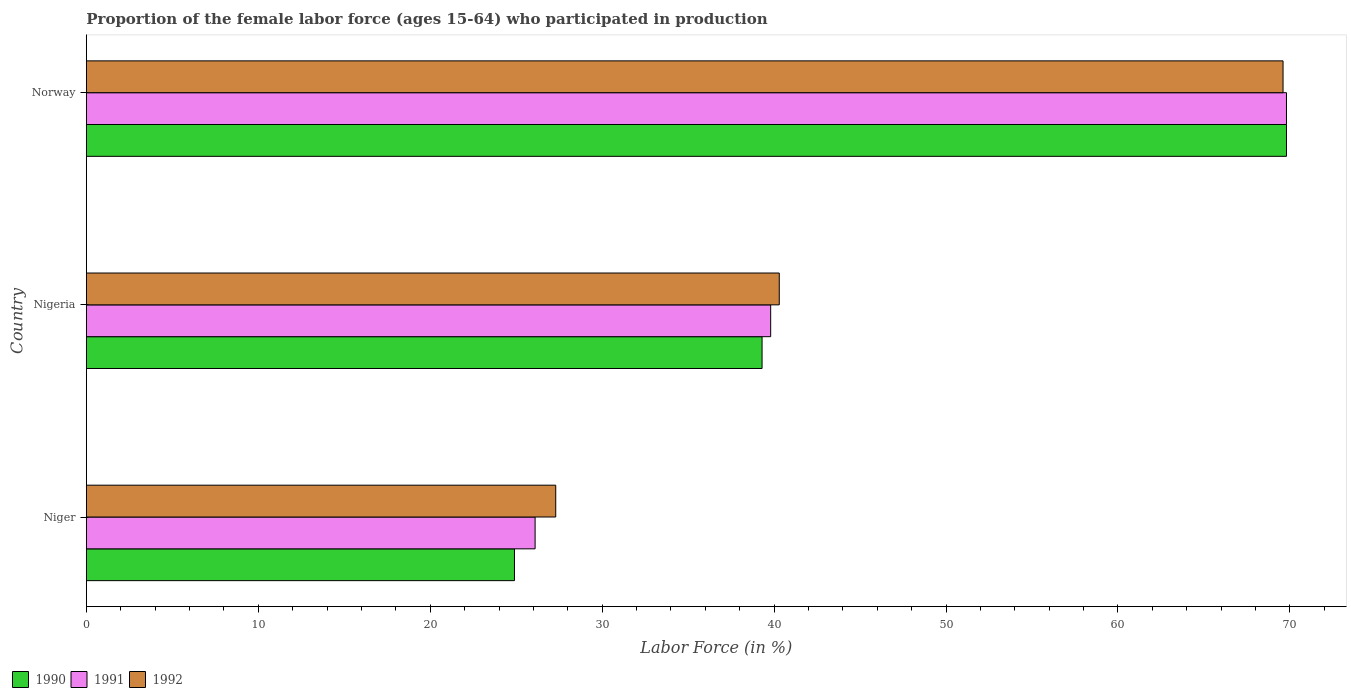How many different coloured bars are there?
Give a very brief answer. 3. Are the number of bars per tick equal to the number of legend labels?
Provide a short and direct response. Yes. Are the number of bars on each tick of the Y-axis equal?
Make the answer very short. Yes. What is the label of the 3rd group of bars from the top?
Your answer should be very brief. Niger. In how many cases, is the number of bars for a given country not equal to the number of legend labels?
Your answer should be very brief. 0. What is the proportion of the female labor force who participated in production in 1990 in Norway?
Your response must be concise. 69.8. Across all countries, what is the maximum proportion of the female labor force who participated in production in 1991?
Provide a succinct answer. 69.8. Across all countries, what is the minimum proportion of the female labor force who participated in production in 1992?
Give a very brief answer. 27.3. In which country was the proportion of the female labor force who participated in production in 1991 maximum?
Keep it short and to the point. Norway. In which country was the proportion of the female labor force who participated in production in 1990 minimum?
Keep it short and to the point. Niger. What is the total proportion of the female labor force who participated in production in 1992 in the graph?
Make the answer very short. 137.2. What is the difference between the proportion of the female labor force who participated in production in 1992 in Niger and that in Nigeria?
Offer a terse response. -13. What is the difference between the proportion of the female labor force who participated in production in 1992 in Norway and the proportion of the female labor force who participated in production in 1990 in Nigeria?
Offer a very short reply. 30.3. What is the average proportion of the female labor force who participated in production in 1992 per country?
Provide a succinct answer. 45.73. What is the difference between the proportion of the female labor force who participated in production in 1991 and proportion of the female labor force who participated in production in 1992 in Niger?
Your response must be concise. -1.2. What is the ratio of the proportion of the female labor force who participated in production in 1991 in Nigeria to that in Norway?
Offer a terse response. 0.57. Is the proportion of the female labor force who participated in production in 1991 in Niger less than that in Norway?
Offer a terse response. Yes. Is the difference between the proportion of the female labor force who participated in production in 1991 in Niger and Nigeria greater than the difference between the proportion of the female labor force who participated in production in 1992 in Niger and Nigeria?
Make the answer very short. No. What is the difference between the highest and the second highest proportion of the female labor force who participated in production in 1991?
Offer a very short reply. 30. What is the difference between the highest and the lowest proportion of the female labor force who participated in production in 1991?
Give a very brief answer. 43.7. Is the sum of the proportion of the female labor force who participated in production in 1990 in Nigeria and Norway greater than the maximum proportion of the female labor force who participated in production in 1992 across all countries?
Offer a terse response. Yes. What does the 3rd bar from the bottom in Norway represents?
Provide a succinct answer. 1992. Is it the case that in every country, the sum of the proportion of the female labor force who participated in production in 1991 and proportion of the female labor force who participated in production in 1992 is greater than the proportion of the female labor force who participated in production in 1990?
Keep it short and to the point. Yes. Are all the bars in the graph horizontal?
Your answer should be very brief. Yes. How many countries are there in the graph?
Your answer should be very brief. 3. What is the difference between two consecutive major ticks on the X-axis?
Provide a succinct answer. 10. Does the graph contain any zero values?
Your answer should be compact. No. Does the graph contain grids?
Provide a short and direct response. No. How many legend labels are there?
Provide a short and direct response. 3. How are the legend labels stacked?
Offer a terse response. Horizontal. What is the title of the graph?
Offer a very short reply. Proportion of the female labor force (ages 15-64) who participated in production. Does "1978" appear as one of the legend labels in the graph?
Offer a terse response. No. What is the Labor Force (in %) of 1990 in Niger?
Your response must be concise. 24.9. What is the Labor Force (in %) in 1991 in Niger?
Provide a succinct answer. 26.1. What is the Labor Force (in %) of 1992 in Niger?
Provide a short and direct response. 27.3. What is the Labor Force (in %) in 1990 in Nigeria?
Your answer should be compact. 39.3. What is the Labor Force (in %) in 1991 in Nigeria?
Provide a short and direct response. 39.8. What is the Labor Force (in %) in 1992 in Nigeria?
Keep it short and to the point. 40.3. What is the Labor Force (in %) of 1990 in Norway?
Your answer should be very brief. 69.8. What is the Labor Force (in %) of 1991 in Norway?
Your answer should be compact. 69.8. What is the Labor Force (in %) of 1992 in Norway?
Keep it short and to the point. 69.6. Across all countries, what is the maximum Labor Force (in %) in 1990?
Provide a short and direct response. 69.8. Across all countries, what is the maximum Labor Force (in %) in 1991?
Provide a short and direct response. 69.8. Across all countries, what is the maximum Labor Force (in %) of 1992?
Offer a terse response. 69.6. Across all countries, what is the minimum Labor Force (in %) of 1990?
Your answer should be very brief. 24.9. Across all countries, what is the minimum Labor Force (in %) of 1991?
Offer a very short reply. 26.1. Across all countries, what is the minimum Labor Force (in %) of 1992?
Offer a very short reply. 27.3. What is the total Labor Force (in %) of 1990 in the graph?
Make the answer very short. 134. What is the total Labor Force (in %) in 1991 in the graph?
Your answer should be very brief. 135.7. What is the total Labor Force (in %) of 1992 in the graph?
Keep it short and to the point. 137.2. What is the difference between the Labor Force (in %) of 1990 in Niger and that in Nigeria?
Make the answer very short. -14.4. What is the difference between the Labor Force (in %) in 1991 in Niger and that in Nigeria?
Offer a terse response. -13.7. What is the difference between the Labor Force (in %) in 1990 in Niger and that in Norway?
Make the answer very short. -44.9. What is the difference between the Labor Force (in %) in 1991 in Niger and that in Norway?
Give a very brief answer. -43.7. What is the difference between the Labor Force (in %) of 1992 in Niger and that in Norway?
Make the answer very short. -42.3. What is the difference between the Labor Force (in %) in 1990 in Nigeria and that in Norway?
Make the answer very short. -30.5. What is the difference between the Labor Force (in %) of 1992 in Nigeria and that in Norway?
Your answer should be very brief. -29.3. What is the difference between the Labor Force (in %) in 1990 in Niger and the Labor Force (in %) in 1991 in Nigeria?
Your answer should be compact. -14.9. What is the difference between the Labor Force (in %) of 1990 in Niger and the Labor Force (in %) of 1992 in Nigeria?
Your response must be concise. -15.4. What is the difference between the Labor Force (in %) of 1990 in Niger and the Labor Force (in %) of 1991 in Norway?
Your answer should be compact. -44.9. What is the difference between the Labor Force (in %) in 1990 in Niger and the Labor Force (in %) in 1992 in Norway?
Your response must be concise. -44.7. What is the difference between the Labor Force (in %) of 1991 in Niger and the Labor Force (in %) of 1992 in Norway?
Your answer should be compact. -43.5. What is the difference between the Labor Force (in %) in 1990 in Nigeria and the Labor Force (in %) in 1991 in Norway?
Keep it short and to the point. -30.5. What is the difference between the Labor Force (in %) in 1990 in Nigeria and the Labor Force (in %) in 1992 in Norway?
Give a very brief answer. -30.3. What is the difference between the Labor Force (in %) of 1991 in Nigeria and the Labor Force (in %) of 1992 in Norway?
Your response must be concise. -29.8. What is the average Labor Force (in %) of 1990 per country?
Provide a short and direct response. 44.67. What is the average Labor Force (in %) in 1991 per country?
Keep it short and to the point. 45.23. What is the average Labor Force (in %) of 1992 per country?
Offer a terse response. 45.73. What is the difference between the Labor Force (in %) of 1990 and Labor Force (in %) of 1991 in Niger?
Keep it short and to the point. -1.2. What is the difference between the Labor Force (in %) of 1991 and Labor Force (in %) of 1992 in Niger?
Offer a terse response. -1.2. What is the difference between the Labor Force (in %) of 1990 and Labor Force (in %) of 1991 in Nigeria?
Give a very brief answer. -0.5. What is the difference between the Labor Force (in %) of 1990 and Labor Force (in %) of 1991 in Norway?
Your answer should be very brief. 0. What is the difference between the Labor Force (in %) in 1990 and Labor Force (in %) in 1992 in Norway?
Ensure brevity in your answer.  0.2. What is the difference between the Labor Force (in %) of 1991 and Labor Force (in %) of 1992 in Norway?
Your answer should be very brief. 0.2. What is the ratio of the Labor Force (in %) of 1990 in Niger to that in Nigeria?
Your answer should be very brief. 0.63. What is the ratio of the Labor Force (in %) of 1991 in Niger to that in Nigeria?
Ensure brevity in your answer.  0.66. What is the ratio of the Labor Force (in %) in 1992 in Niger to that in Nigeria?
Your answer should be compact. 0.68. What is the ratio of the Labor Force (in %) of 1990 in Niger to that in Norway?
Your answer should be very brief. 0.36. What is the ratio of the Labor Force (in %) in 1991 in Niger to that in Norway?
Your answer should be compact. 0.37. What is the ratio of the Labor Force (in %) of 1992 in Niger to that in Norway?
Your answer should be compact. 0.39. What is the ratio of the Labor Force (in %) of 1990 in Nigeria to that in Norway?
Offer a very short reply. 0.56. What is the ratio of the Labor Force (in %) of 1991 in Nigeria to that in Norway?
Your answer should be very brief. 0.57. What is the ratio of the Labor Force (in %) of 1992 in Nigeria to that in Norway?
Your response must be concise. 0.58. What is the difference between the highest and the second highest Labor Force (in %) of 1990?
Your answer should be compact. 30.5. What is the difference between the highest and the second highest Labor Force (in %) of 1991?
Offer a very short reply. 30. What is the difference between the highest and the second highest Labor Force (in %) of 1992?
Give a very brief answer. 29.3. What is the difference between the highest and the lowest Labor Force (in %) of 1990?
Keep it short and to the point. 44.9. What is the difference between the highest and the lowest Labor Force (in %) of 1991?
Offer a terse response. 43.7. What is the difference between the highest and the lowest Labor Force (in %) of 1992?
Give a very brief answer. 42.3. 